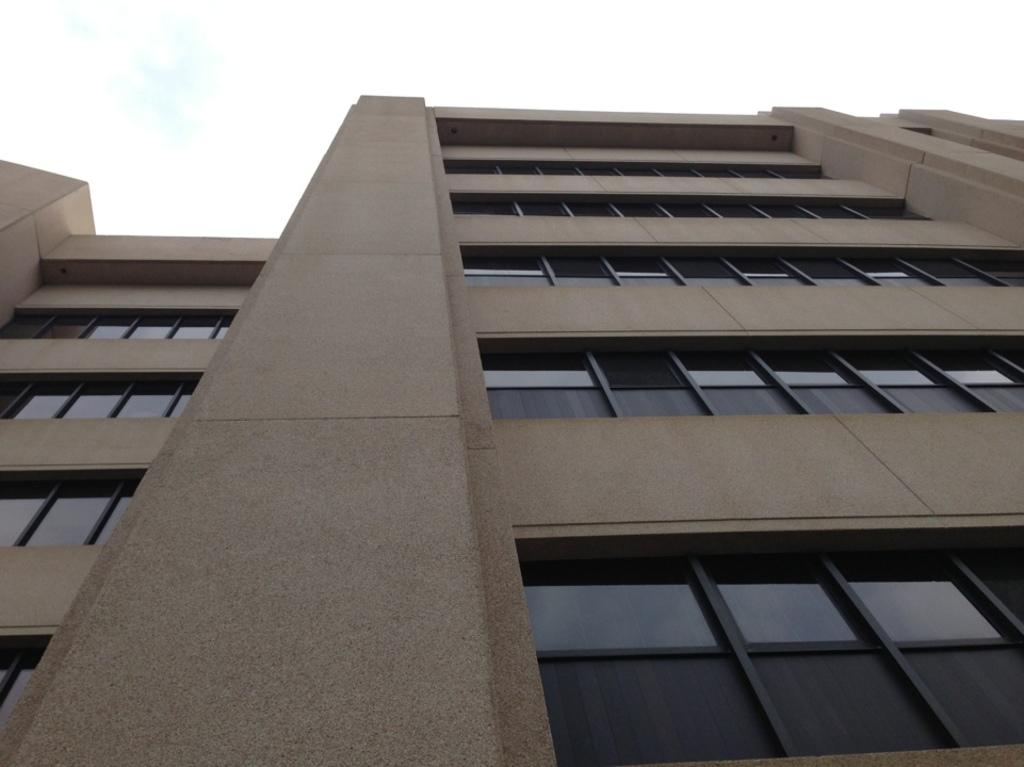What type of structure is present in the image? There is a building in the image. What material are the windows of the building made of? The windows of the building are made of glass. What type of quill can be seen in the image? There is no quill present in the image; it only features a building with glass windows. 